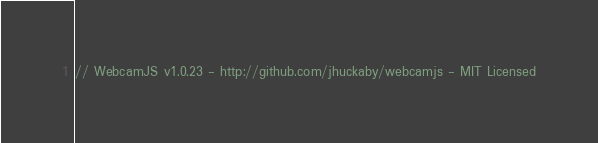Convert code to text. <code><loc_0><loc_0><loc_500><loc_500><_JavaScript_>// WebcamJS v1.0.23 - http://github.com/jhuckaby/webcamjs - MIT Licensed</code> 